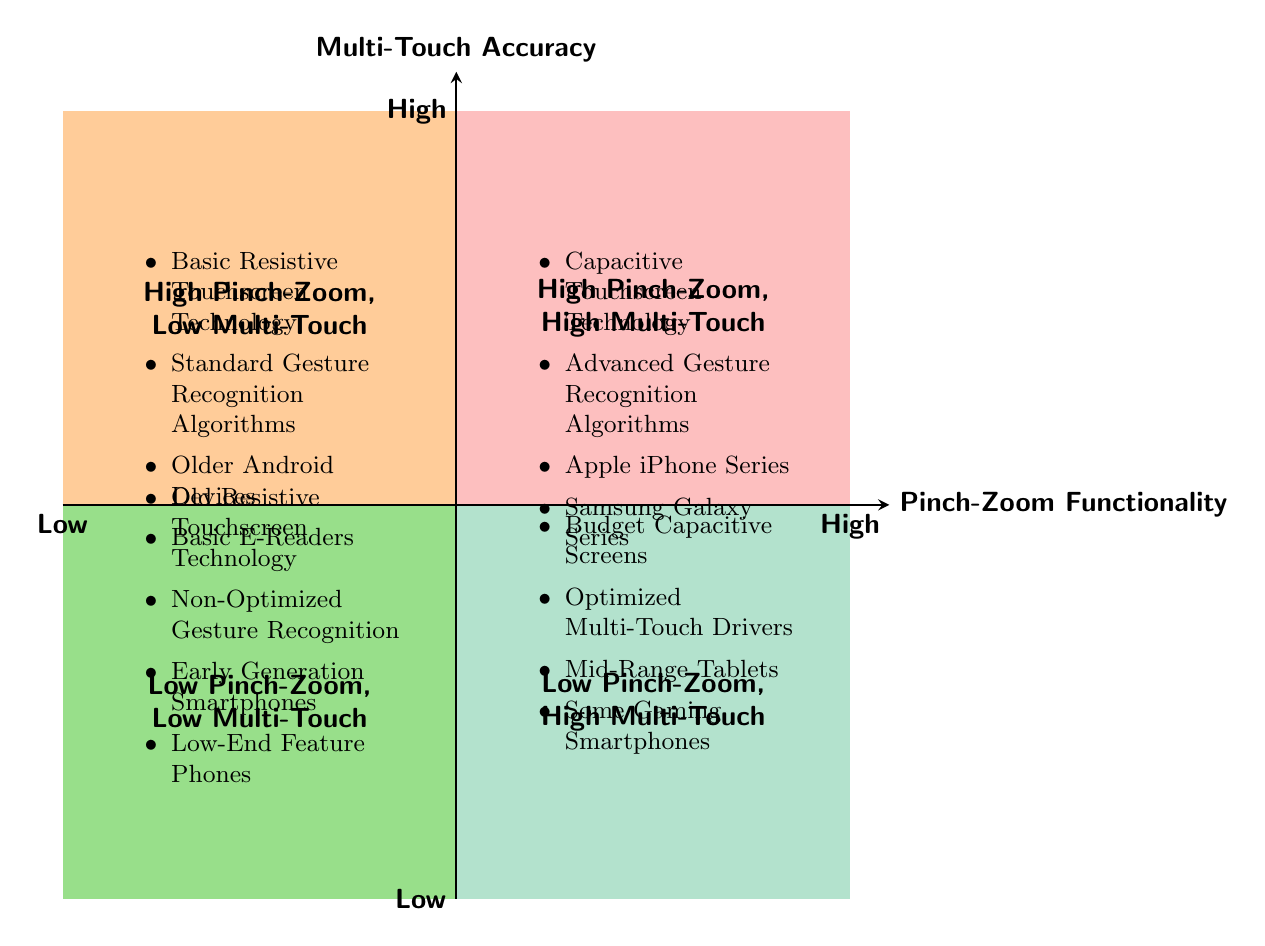What items are listed in the High Pinch-Zoom Performance and High Multi-Touch Accuracy quadrant? In the diagram, the quadrant labeled "High Pinch-Zoom Performance, High Multi-Touch Accuracy" includes items such as "Capacitive Touchscreen Technology," "Advanced Gesture Recognition Algorithms," "Apple iPhone Series," and "Samsung Galaxy Series."
Answer: Capacitive Touchscreen Technology, Advanced Gesture Recognition Algorithms, Apple iPhone Series, Samsung Galaxy Series Which quadrant contains devices with Low Pinch-Zoom Performance but High Multi-Touch Accuracy? The quadrant that includes devices with "Low Pinch-Zoom Performance" but "High Multi-Touch Accuracy" is titled "Low Pinch-Zoom, High Multi-Touch."
Answer: Low Pinch-Zoom, High Multi-Touch How many items are present in the Low Pinch-Zoom Performance and Low Multi-Touch Accuracy quadrant? In the quadrant labeled "Low Pinch-Zoom Performance, Low Multi-Touch Accuracy," there are four items listed, which are "Old Resistive Touchscreen Technology," "Non-Optimized Gesture Recognition," "Early Generation Smartphones," and "Low-End Feature Phones."
Answer: 4 What technology is associated with High Pinch-Zoom Performance but Low Multi-Touch Accuracy? The quadrant that indicates "High Pinch-Zoom Performance" and "Low Multi-Touch Accuracy" lists technologies such as "Basic Resistive Touchscreen Technology" and "Standard Gesture Recognition Algorithms."
Answer: Basic Resistive Touchscreen Technology, Standard Gesture Recognition Algorithms Which quadrant includes older Android devices? The quadrant that includes "Older Android Devices" is labeled "High Pinch-Zoom Performance, Low Multi-Touch Accuracy."
Answer: High Pinch-Zoom Performance, Low Multi-Touch Accuracy What type of smartphones are mentioned in the Low Pinch-Zoom, High Multi-Touch quadrant? The devices in the "Low Pinch-Zoom, High Multi-Touch" quadrant include "Mid-Range Tablets" and "Some Gaming Smartphones."
Answer: Mid-Range Tablets, Some Gaming Smartphones How do High Pinch-Zoom and High Multi-Touch categories compare? Devices in the "High Pinch-Zoom Performance, High Multi-Touch Accuracy" quadrant outperform those in the "High Pinch-Zoom Performance, Low Multi-Touch Accuracy" quadrant in both functionalities, thereby providing better user experience overall.
Answer: Better user experience overall 